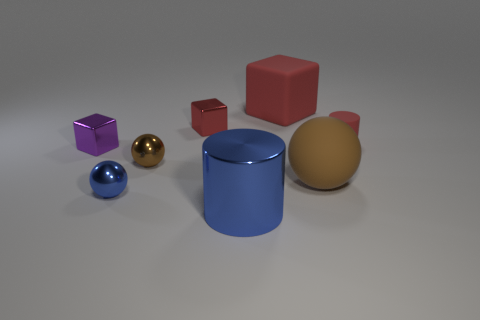Subtract all purple balls. Subtract all purple cylinders. How many balls are left? 3 Add 1 big shiny objects. How many objects exist? 9 Subtract all cylinders. How many objects are left? 6 Add 6 shiny cylinders. How many shiny cylinders are left? 7 Add 2 small metal blocks. How many small metal blocks exist? 4 Subtract 0 green balls. How many objects are left? 8 Subtract all small red metal things. Subtract all large blue things. How many objects are left? 6 